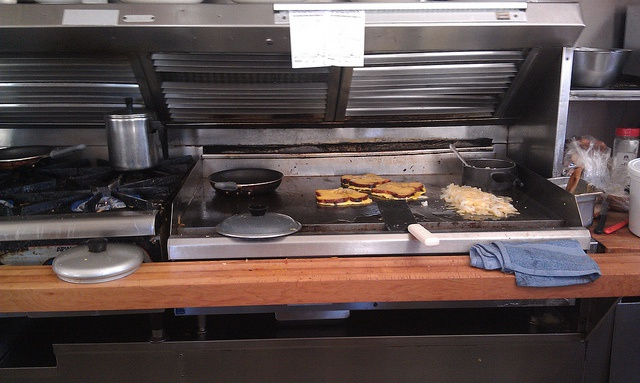Describe the objects in this image and their specific colors. I can see oven in darkgray, black, and gray tones, bowl in darkgray, gray, and black tones, knife in darkgray, black, white, gray, and pink tones, sandwich in darkgray, tan, maroon, and brown tones, and sandwich in darkgray, tan, maroon, and gray tones in this image. 